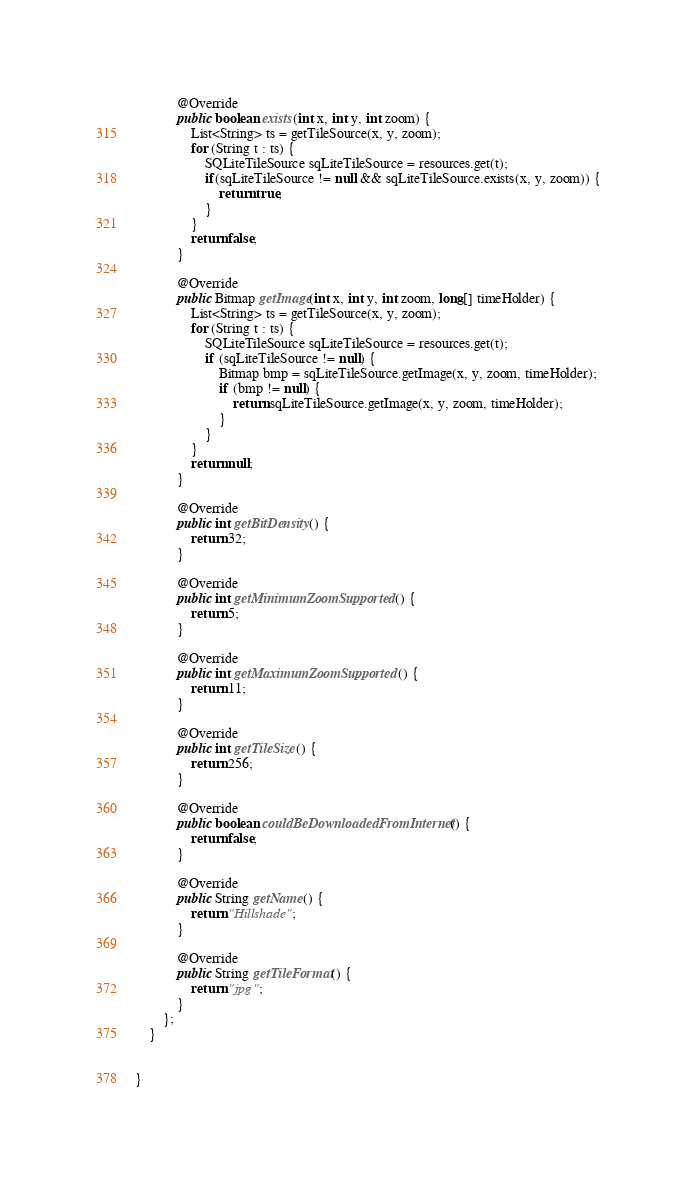Convert code to text. <code><loc_0><loc_0><loc_500><loc_500><_Java_>			@Override
			public boolean exists(int x, int y, int zoom) {
				List<String> ts = getTileSource(x, y, zoom);
				for (String t : ts) {
					SQLiteTileSource sqLiteTileSource = resources.get(t);
					if(sqLiteTileSource != null && sqLiteTileSource.exists(x, y, zoom)) {
						return true;
					}
				}
				return false;
			}
			
			@Override
			public Bitmap getImage(int x, int y, int zoom, long[] timeHolder) {
				List<String> ts = getTileSource(x, y, zoom);
				for (String t : ts) {
					SQLiteTileSource sqLiteTileSource = resources.get(t);
					if (sqLiteTileSource != null) {
						Bitmap bmp = sqLiteTileSource.getImage(x, y, zoom, timeHolder);
						if (bmp != null) {
							return sqLiteTileSource.getImage(x, y, zoom, timeHolder);
						}
					}
				}
				return null;
			}
			
			@Override
			public int getBitDensity() {
				return 32;
			}
			
			@Override
			public int getMinimumZoomSupported() {
				return 5;
			}
			
			@Override
			public int getMaximumZoomSupported() {
				return 11;
			}
			
			@Override
			public int getTileSize() {
				return 256;
			}
			
			@Override
			public boolean couldBeDownloadedFromInternet() {
				return false;
			}
			
			@Override
			public String getName() {
				return "Hillshade";
			}
			
			@Override
			public String getTileFormat() {
				return "jpg";
			}
		};
	}
	

}
</code> 